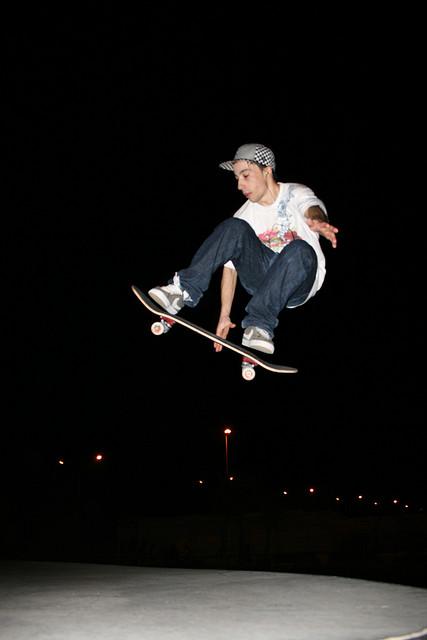What pattern is on the man's shirt?
Give a very brief answer. Plain. What sport is the athlete performing?
Be succinct. Skateboarding. Is it day or night?
Short answer required. Night. Who is in the air?
Answer briefly. Skateboarder. What type of hat is the man wearing?
Keep it brief. Baseball. Are they outdoors or indoors?
Keep it brief. Outdoors. What color is the man's cap?
Be succinct. Gray. Is this a skate park?
Keep it brief. Yes. How many wheels are not touching the ground?
Answer briefly. 4. What is the person in the picture riding?
Give a very brief answer. Skateboard. Is he wearing a hat?
Give a very brief answer. Yes. Is this skateboarder at least 10 centimeters above the coping of the ramp?
Give a very brief answer. Yes. Why is this man slightly squatting?
Be succinct. Skateboarding. Is it day time?
Short answer required. No. Is the person flipping a skateboard?
Short answer required. No. Which hand is touching the skateboard?
Write a very short answer. Right. Is he in midair?
Give a very brief answer. Yes. Is there snow on the ground?
Answer briefly. No. Where is the man's left hand?
Write a very short answer. In air. What is the man doing while skateboarding?
Give a very brief answer. Jumping. How many of the man's feet are on the board?
Short answer required. 2. 